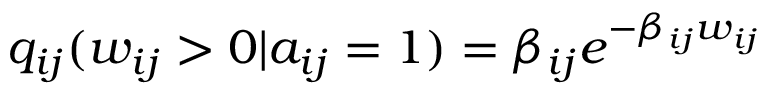Convert formula to latex. <formula><loc_0><loc_0><loc_500><loc_500>q _ { i j } ( w _ { i j } > 0 | a _ { i j } = 1 ) = \beta _ { i j } e ^ { - \beta _ { i j } w _ { i j } }</formula> 